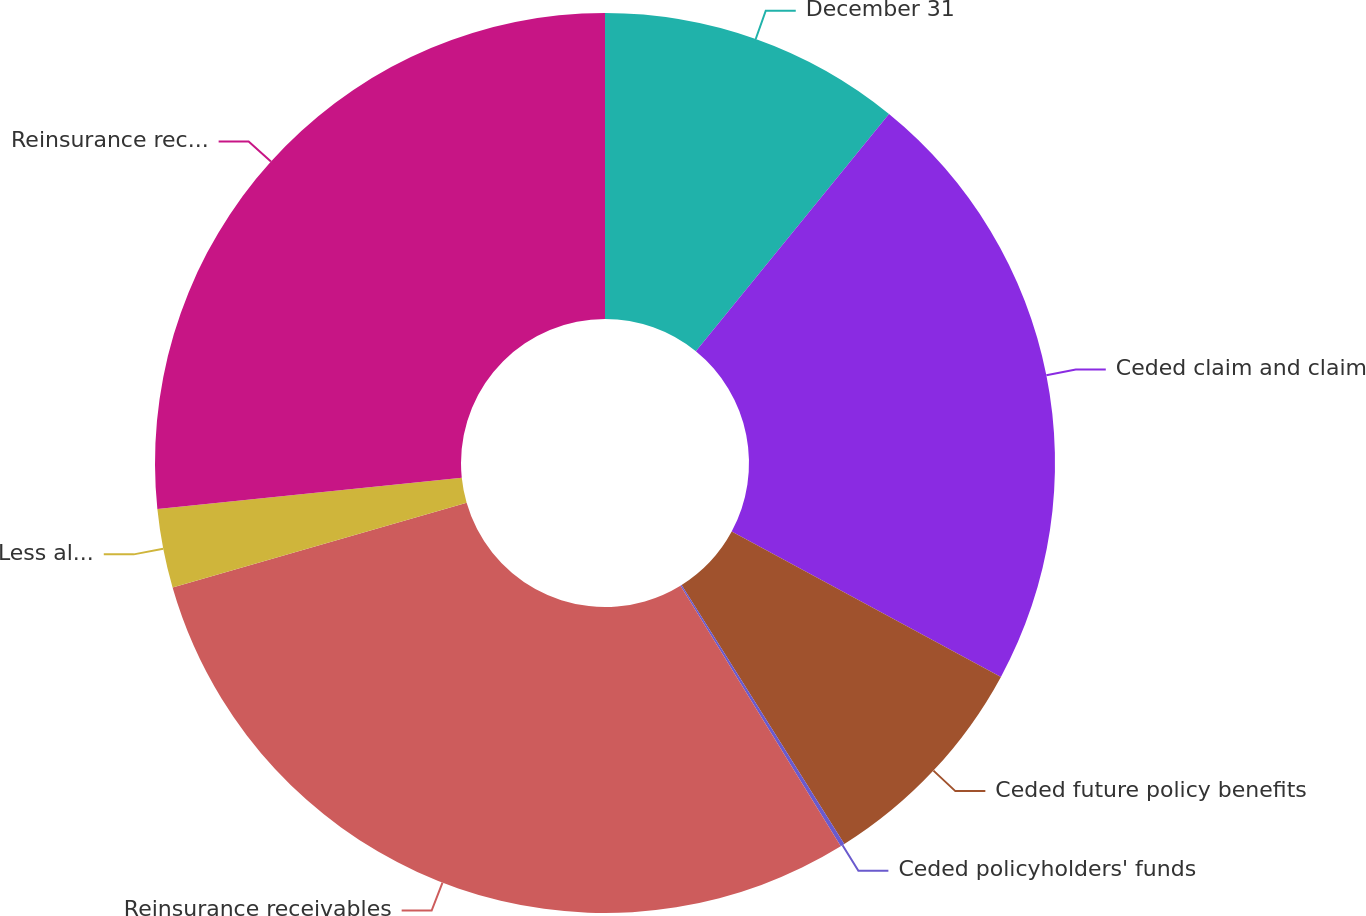<chart> <loc_0><loc_0><loc_500><loc_500><pie_chart><fcel>December 31<fcel>Ceded claim and claim<fcel>Ceded future policy benefits<fcel>Ceded policyholders' funds<fcel>Reinsurance receivables<fcel>Less allowance for doubtful<fcel>Reinsurance receivables net of<nl><fcel>10.87%<fcel>22.01%<fcel>8.19%<fcel>0.15%<fcel>29.31%<fcel>2.83%<fcel>26.63%<nl></chart> 